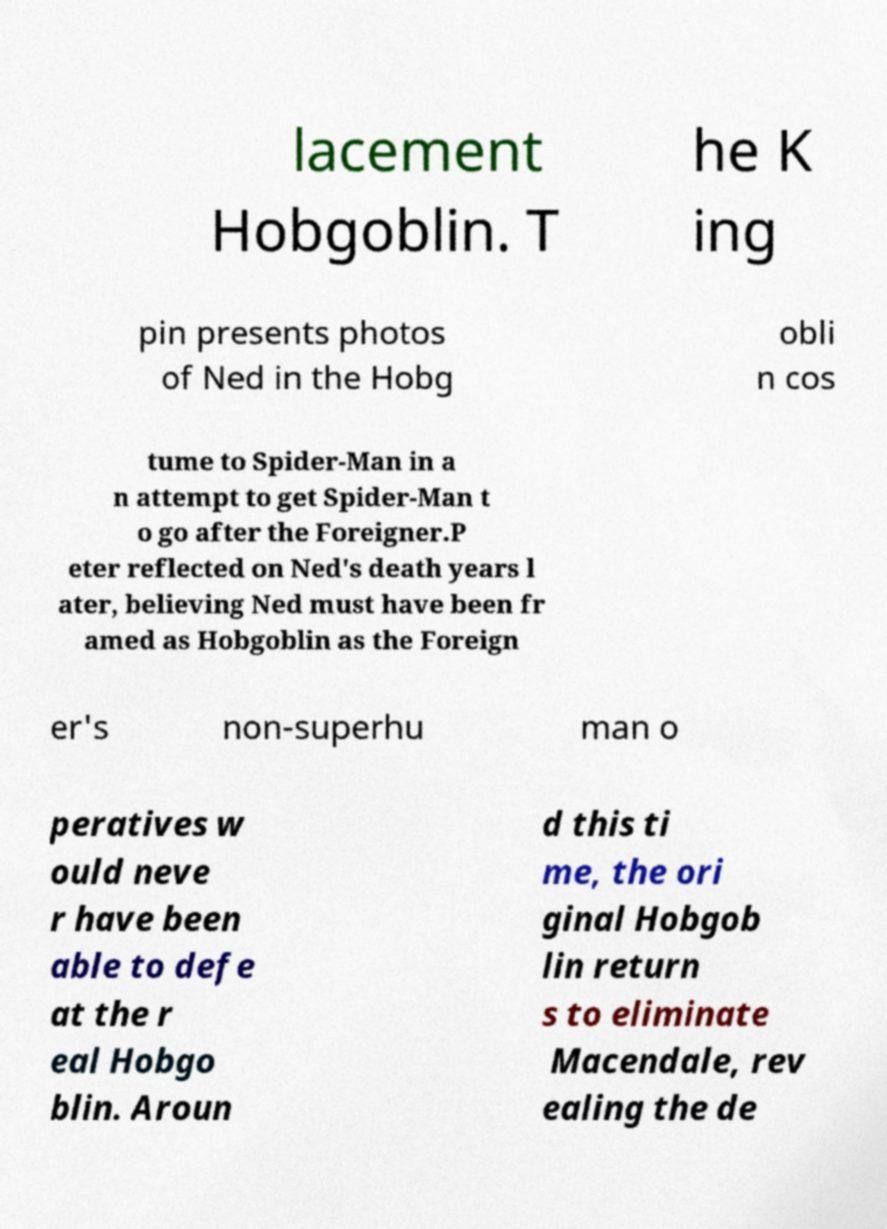Could you assist in decoding the text presented in this image and type it out clearly? lacement Hobgoblin. T he K ing pin presents photos of Ned in the Hobg obli n cos tume to Spider-Man in a n attempt to get Spider-Man t o go after the Foreigner.P eter reflected on Ned's death years l ater, believing Ned must have been fr amed as Hobgoblin as the Foreign er's non-superhu man o peratives w ould neve r have been able to defe at the r eal Hobgo blin. Aroun d this ti me, the ori ginal Hobgob lin return s to eliminate Macendale, rev ealing the de 